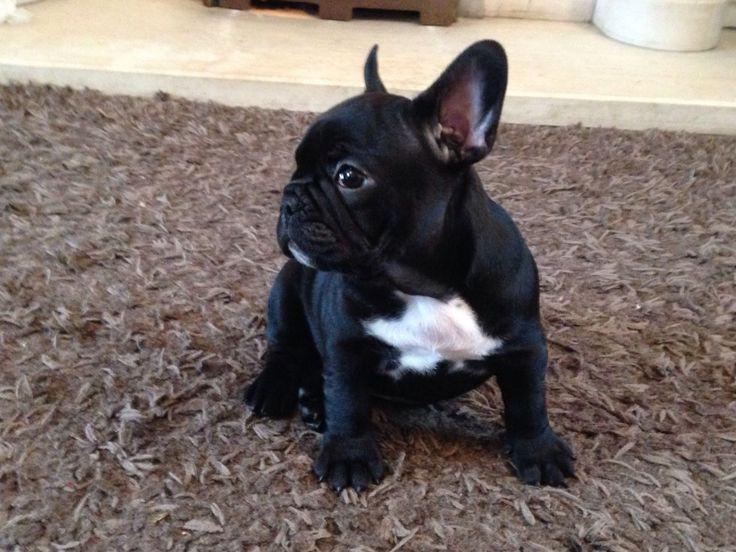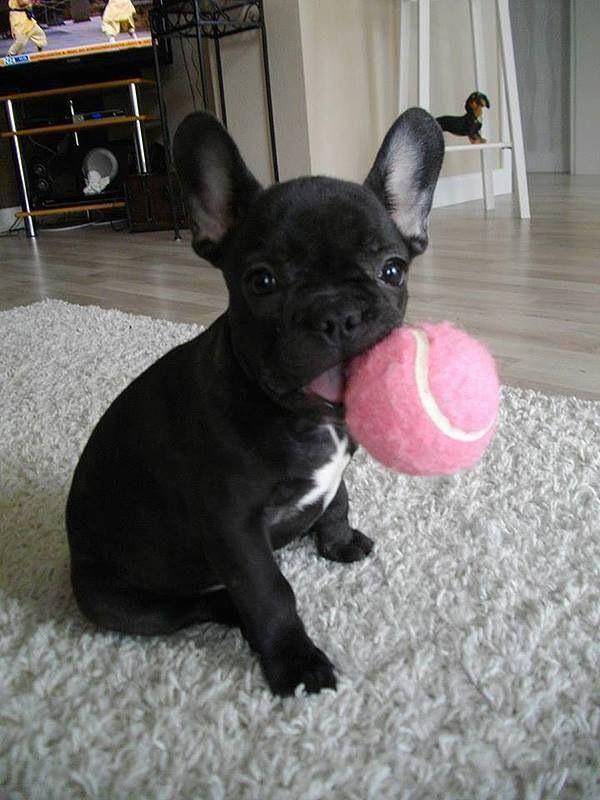The first image is the image on the left, the second image is the image on the right. Examine the images to the left and right. Is the description "A single French Bulldog is standing up in the grass." accurate? Answer yes or no. No. 